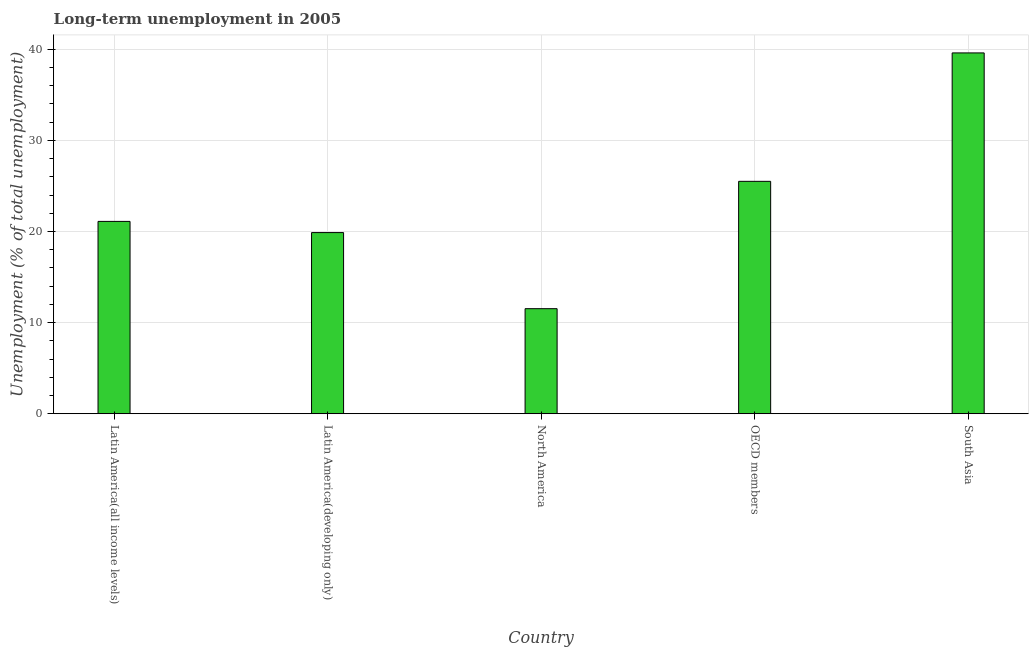What is the title of the graph?
Make the answer very short. Long-term unemployment in 2005. What is the label or title of the Y-axis?
Keep it short and to the point. Unemployment (% of total unemployment). What is the long-term unemployment in Latin America(all income levels)?
Offer a very short reply. 21.11. Across all countries, what is the maximum long-term unemployment?
Provide a succinct answer. 39.6. Across all countries, what is the minimum long-term unemployment?
Provide a succinct answer. 11.53. What is the sum of the long-term unemployment?
Keep it short and to the point. 117.63. What is the difference between the long-term unemployment in North America and South Asia?
Offer a terse response. -28.07. What is the average long-term unemployment per country?
Offer a terse response. 23.53. What is the median long-term unemployment?
Offer a terse response. 21.11. What is the ratio of the long-term unemployment in Latin America(all income levels) to that in North America?
Ensure brevity in your answer.  1.83. What is the difference between the highest and the second highest long-term unemployment?
Provide a succinct answer. 14.09. What is the difference between the highest and the lowest long-term unemployment?
Your response must be concise. 28.07. In how many countries, is the long-term unemployment greater than the average long-term unemployment taken over all countries?
Your answer should be compact. 2. Are all the bars in the graph horizontal?
Your answer should be very brief. No. What is the difference between two consecutive major ticks on the Y-axis?
Give a very brief answer. 10. Are the values on the major ticks of Y-axis written in scientific E-notation?
Give a very brief answer. No. What is the Unemployment (% of total unemployment) in Latin America(all income levels)?
Keep it short and to the point. 21.11. What is the Unemployment (% of total unemployment) in Latin America(developing only)?
Provide a short and direct response. 19.88. What is the Unemployment (% of total unemployment) in North America?
Ensure brevity in your answer.  11.53. What is the Unemployment (% of total unemployment) of OECD members?
Your answer should be very brief. 25.51. What is the Unemployment (% of total unemployment) of South Asia?
Your response must be concise. 39.6. What is the difference between the Unemployment (% of total unemployment) in Latin America(all income levels) and Latin America(developing only)?
Your response must be concise. 1.23. What is the difference between the Unemployment (% of total unemployment) in Latin America(all income levels) and North America?
Ensure brevity in your answer.  9.58. What is the difference between the Unemployment (% of total unemployment) in Latin America(all income levels) and OECD members?
Offer a terse response. -4.4. What is the difference between the Unemployment (% of total unemployment) in Latin America(all income levels) and South Asia?
Make the answer very short. -18.49. What is the difference between the Unemployment (% of total unemployment) in Latin America(developing only) and North America?
Your answer should be very brief. 8.35. What is the difference between the Unemployment (% of total unemployment) in Latin America(developing only) and OECD members?
Your answer should be compact. -5.63. What is the difference between the Unemployment (% of total unemployment) in Latin America(developing only) and South Asia?
Your answer should be compact. -19.72. What is the difference between the Unemployment (% of total unemployment) in North America and OECD members?
Offer a very short reply. -13.98. What is the difference between the Unemployment (% of total unemployment) in North America and South Asia?
Your response must be concise. -28.07. What is the difference between the Unemployment (% of total unemployment) in OECD members and South Asia?
Ensure brevity in your answer.  -14.09. What is the ratio of the Unemployment (% of total unemployment) in Latin America(all income levels) to that in Latin America(developing only)?
Your answer should be very brief. 1.06. What is the ratio of the Unemployment (% of total unemployment) in Latin America(all income levels) to that in North America?
Ensure brevity in your answer.  1.83. What is the ratio of the Unemployment (% of total unemployment) in Latin America(all income levels) to that in OECD members?
Offer a terse response. 0.83. What is the ratio of the Unemployment (% of total unemployment) in Latin America(all income levels) to that in South Asia?
Your answer should be very brief. 0.53. What is the ratio of the Unemployment (% of total unemployment) in Latin America(developing only) to that in North America?
Provide a succinct answer. 1.72. What is the ratio of the Unemployment (% of total unemployment) in Latin America(developing only) to that in OECD members?
Provide a succinct answer. 0.78. What is the ratio of the Unemployment (% of total unemployment) in Latin America(developing only) to that in South Asia?
Provide a succinct answer. 0.5. What is the ratio of the Unemployment (% of total unemployment) in North America to that in OECD members?
Make the answer very short. 0.45. What is the ratio of the Unemployment (% of total unemployment) in North America to that in South Asia?
Offer a terse response. 0.29. What is the ratio of the Unemployment (% of total unemployment) in OECD members to that in South Asia?
Offer a terse response. 0.64. 